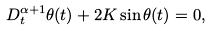<formula> <loc_0><loc_0><loc_500><loc_500>D ^ { \alpha + 1 } _ { t } \theta ( t ) + 2 K \sin \theta ( t ) = 0 ,</formula> 